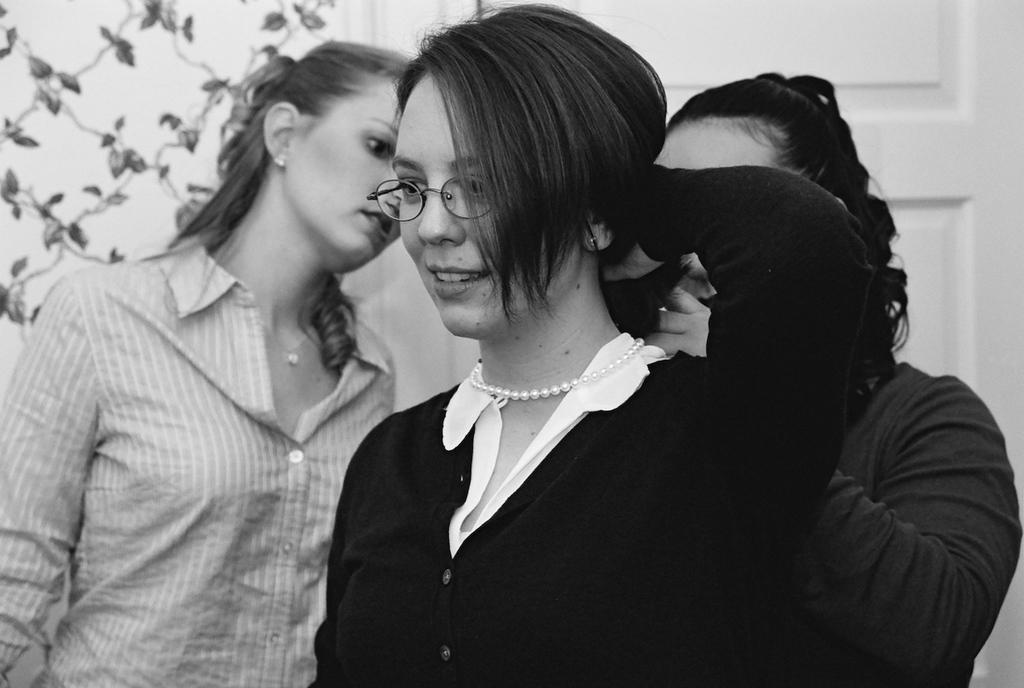How many people are in the image? There are 2 women and a person in the image, making a total of 3 individuals. What are the people in the image doing? All three individuals are standing. What is the color scheme of the image? The image is in black and white. What type of stitch is being used to sew the underwear in the image? There is no underwear or stitching present in the image. What kind of bun is the person wearing in the image? There is no bun visible on any of the individuals in the image. 